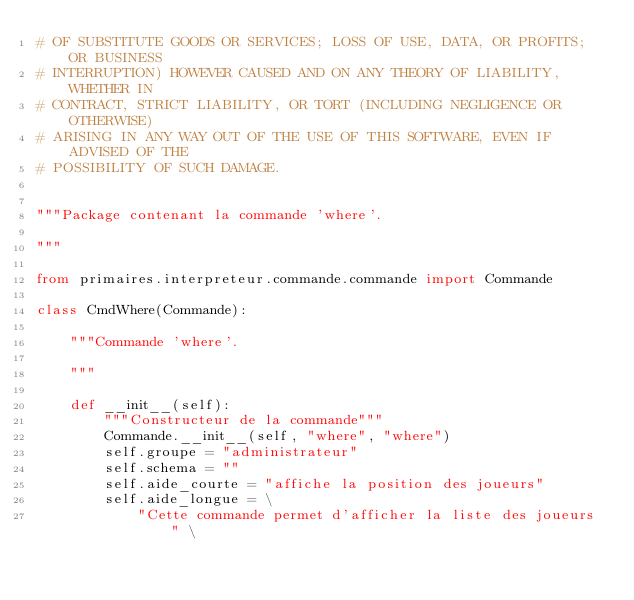<code> <loc_0><loc_0><loc_500><loc_500><_Python_># OF SUBSTITUTE GOODS OR SERVICES; LOSS OF USE, DATA, OR PROFITS; OR BUSINESS
# INTERRUPTION) HOWEVER CAUSED AND ON ANY THEORY OF LIABILITY, WHETHER IN
# CONTRACT, STRICT LIABILITY, OR TORT (INCLUDING NEGLIGENCE OR OTHERWISE)
# ARISING IN ANY WAY OUT OF THE USE OF THIS SOFTWARE, EVEN IF ADVISED OF THE
# POSSIBILITY OF SUCH DAMAGE.


"""Package contenant la commande 'where'.

"""

from primaires.interpreteur.commande.commande import Commande

class CmdWhere(Commande):
    
    """Commande 'where'.
    
    """
    
    def __init__(self):
        """Constructeur de la commande"""
        Commande.__init__(self, "where", "where")
        self.groupe = "administrateur"
        self.schema = ""
        self.aide_courte = "affiche la position des joueurs"
        self.aide_longue = \
            "Cette commande permet d'afficher la liste des joueurs " \</code> 